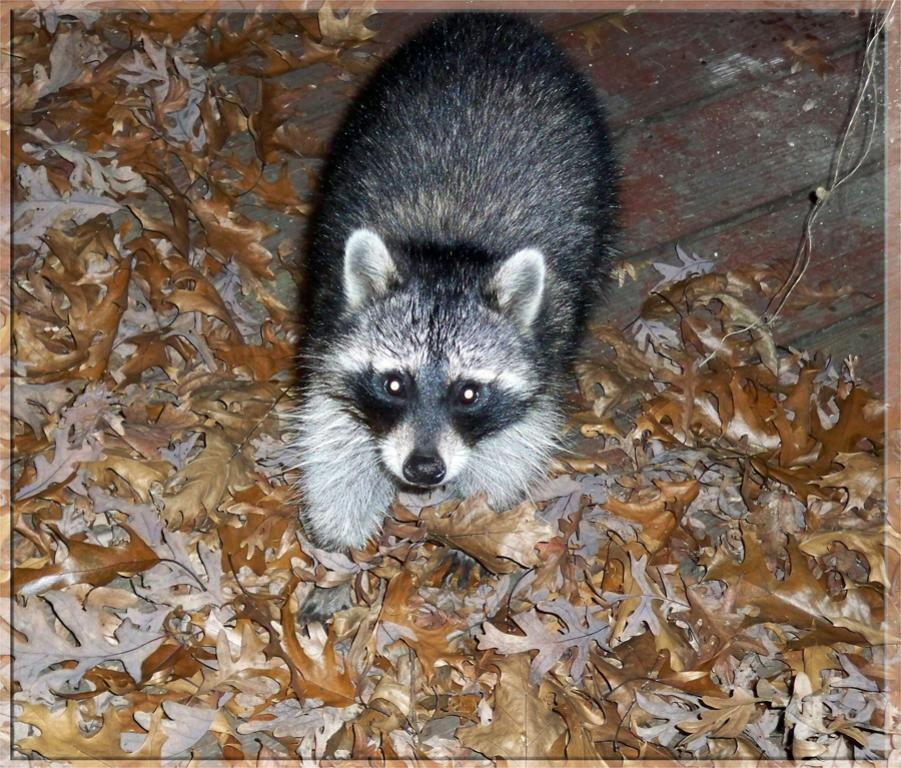What type of creature is present in the image? There is an animal in the image. Can you describe the animal's position or posture? The animal is sitting on dry leaves. Is the woman in the image applying a wound dressing to the animal? There is no woman present in the image, and therefore no such activity can be observed. 